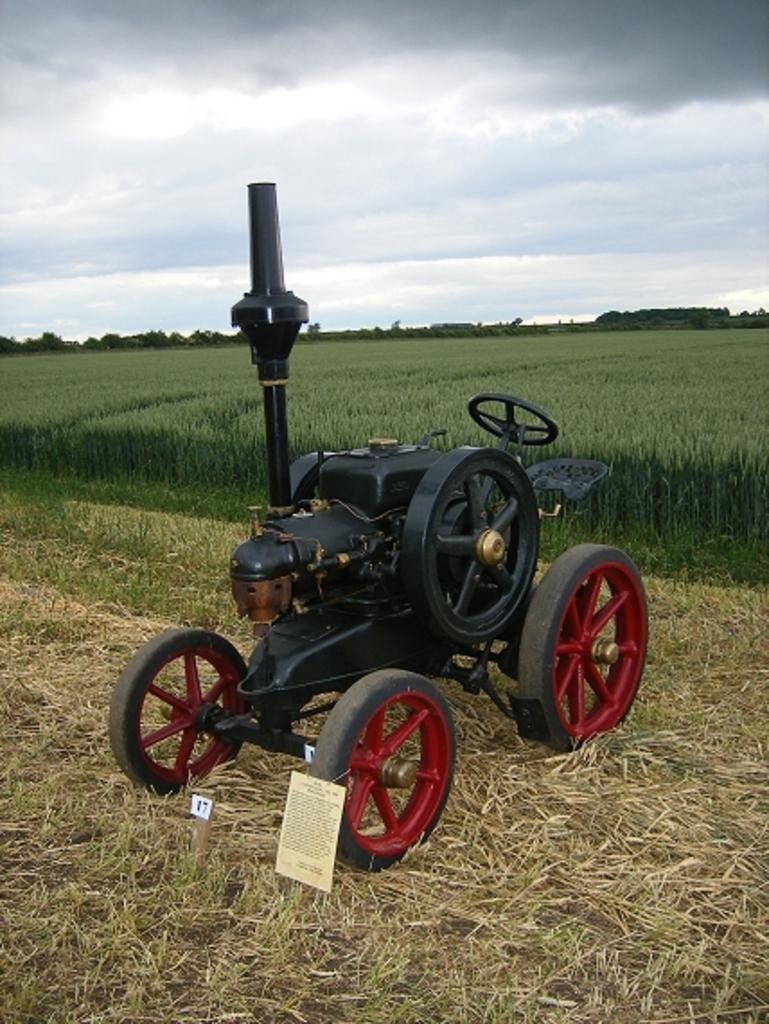In one or two sentences, can you explain what this image depicts? In the image we can see a vehicle, this is a dry grass, grass, plant, trees and a cloudy sky. 